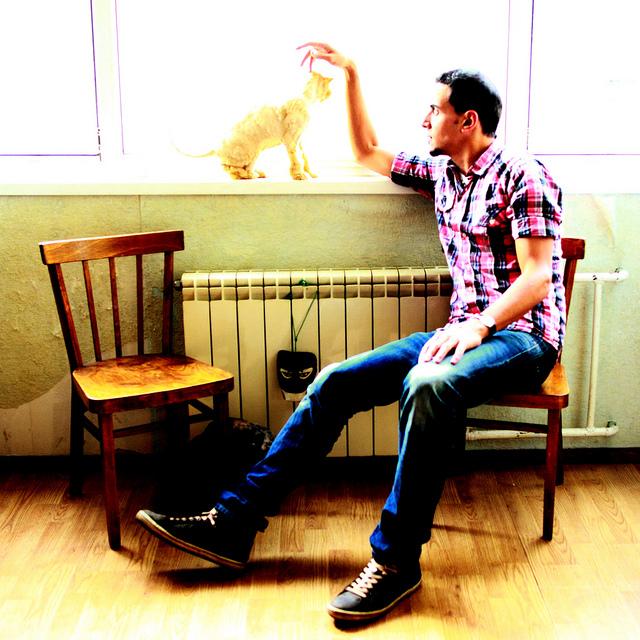How many chairs that are empty?
Be succinct. 1. What is hanging from the radiator?
Short answer required. Mask. Is the animal on the windowsill domesticated?
Concise answer only. Yes. 